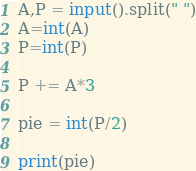Convert code to text. <code><loc_0><loc_0><loc_500><loc_500><_Python_>A,P = input().split(" ")
A=int(A)
P=int(P)

P += A*3

pie = int(P/2)

print(pie)</code> 